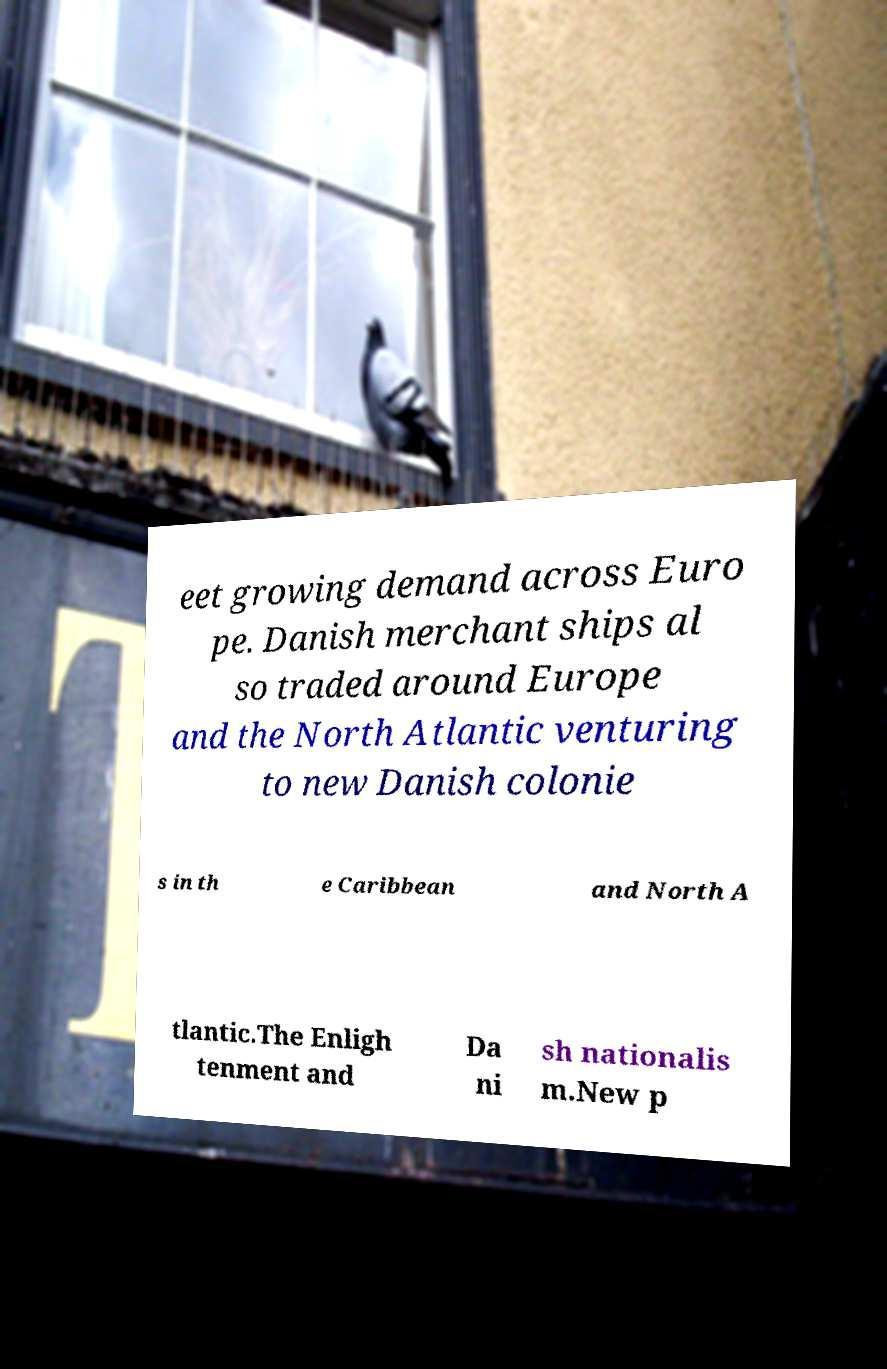Could you assist in decoding the text presented in this image and type it out clearly? eet growing demand across Euro pe. Danish merchant ships al so traded around Europe and the North Atlantic venturing to new Danish colonie s in th e Caribbean and North A tlantic.The Enligh tenment and Da ni sh nationalis m.New p 